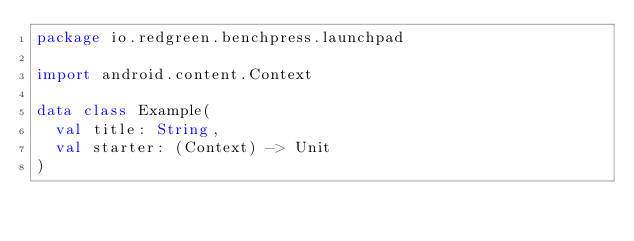Convert code to text. <code><loc_0><loc_0><loc_500><loc_500><_Kotlin_>package io.redgreen.benchpress.launchpad

import android.content.Context

data class Example(
  val title: String,
  val starter: (Context) -> Unit
)
</code> 